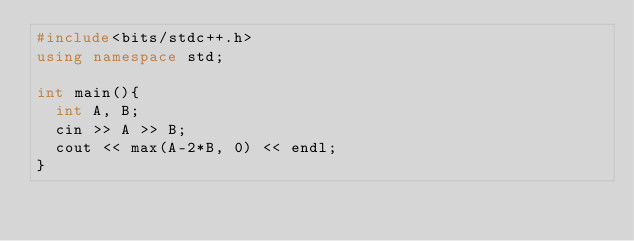<code> <loc_0><loc_0><loc_500><loc_500><_C++_>#include<bits/stdc++.h>
using namespace std;

int main(){
  int A, B;
  cin >> A >> B;
  cout << max(A-2*B, 0) << endl;
}</code> 